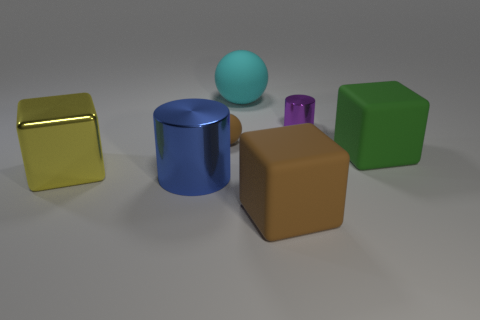Subtract all big matte cubes. How many cubes are left? 1 Subtract 1 cubes. How many cubes are left? 2 Add 1 large brown rubber things. How many objects exist? 8 Subtract all purple blocks. Subtract all yellow balls. How many blocks are left? 3 Subtract all cylinders. How many objects are left? 5 Add 1 cylinders. How many cylinders are left? 3 Add 2 green rubber objects. How many green rubber objects exist? 3 Subtract 1 purple cylinders. How many objects are left? 6 Subtract all big things. Subtract all small cyan cylinders. How many objects are left? 2 